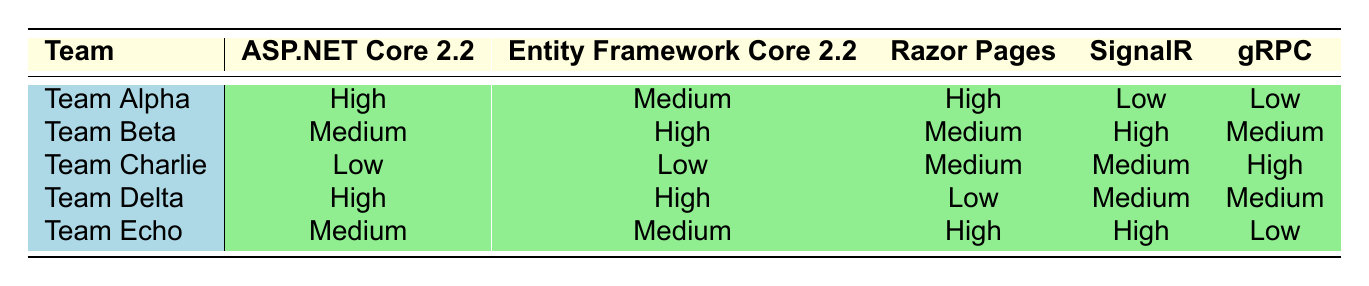What is Team Alpha's adoption level for ASP.NET Core 2.2? According to the table, Team Alpha's adoption level for ASP.NET Core 2.2 is listed as "High."
Answer: High Which team has the highest adoption level for Entity Framework Core 2.2? From the table, both Team Beta and Team Delta have an adoption level of "High" for Entity Framework Core 2.2, making them the teams with the highest level.
Answer: Team Beta, Team Delta Do any teams have a low adoption level for SignalR? In the table, Team Alpha has "Low" for SignalR.
Answer: Yes What feature has the lowest overall adoption across all teams? Evaluating the adoption levels, "gRPC" shows "Low" for Team Alpha, Team Beta, and Team Delta, and "Medium" for Team Charlie, making it the feature with the lowest overall high adoption.
Answer: gRPC What is the average adoption level for Razor Pages across all teams, considering High = 3, Medium = 2, and Low = 1? Razor Pages has the following levels: Team Alpha = High (3), Team Beta = Medium (2), Team Charlie = Medium (2), Team Delta = Low (1), Team Echo = High (3). The sum is (3 + 2 + 2 + 1 + 3) = 11, and there are 5 teams, so the average is 11/5 = 2.2, which is less than "High" but greater than "Medium."
Answer: Average is 2.2 Which team has a higher adoption level for gRPC: Team Charlie or Team Echo? In the table, Team Charlie has "High" for gRPC and Team Echo has "Low," showing that Team Charlie has a higher adoption level for gRPC.
Answer: Team Charlie 